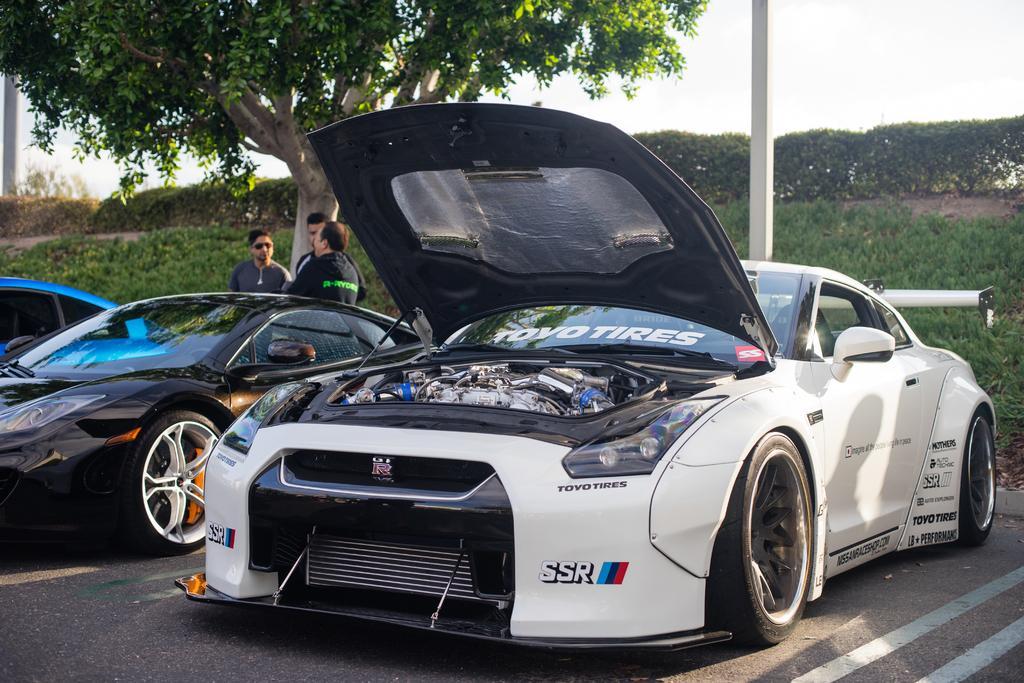Can you describe this image briefly? In the picture we can see some cars are parked on the path and behind the cars we can see some people are standing and talking and behind them, we can see a tree and besides, we can see a pole and in the background we can see a grass surface, plants and sky. 